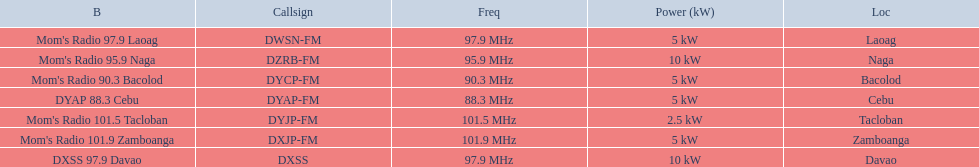What are the frequencies for radios of dyap-fm? 97.9 MHz, 95.9 MHz, 90.3 MHz, 88.3 MHz, 101.5 MHz, 101.9 MHz, 97.9 MHz. What is the lowest frequency? 88.3 MHz. Which radio has this frequency? DYAP 88.3 Cebu. 